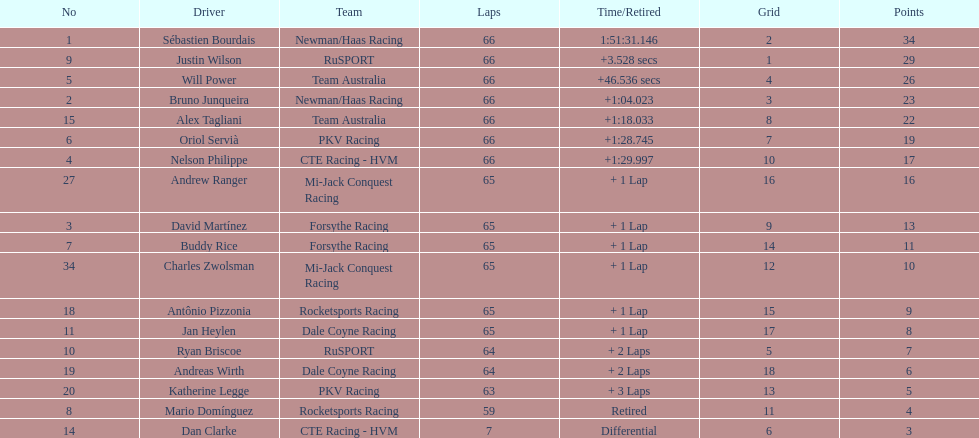How many drivers did not make more than 60 laps? 2. Write the full table. {'header': ['No', 'Driver', 'Team', 'Laps', 'Time/Retired', 'Grid', 'Points'], 'rows': [['1', 'Sébastien Bourdais', 'Newman/Haas Racing', '66', '1:51:31.146', '2', '34'], ['9', 'Justin Wilson', 'RuSPORT', '66', '+3.528 secs', '1', '29'], ['5', 'Will Power', 'Team Australia', '66', '+46.536 secs', '4', '26'], ['2', 'Bruno Junqueira', 'Newman/Haas Racing', '66', '+1:04.023', '3', '23'], ['15', 'Alex Tagliani', 'Team Australia', '66', '+1:18.033', '8', '22'], ['6', 'Oriol Servià', 'PKV Racing', '66', '+1:28.745', '7', '19'], ['4', 'Nelson Philippe', 'CTE Racing - HVM', '66', '+1:29.997', '10', '17'], ['27', 'Andrew Ranger', 'Mi-Jack Conquest Racing', '65', '+ 1 Lap', '16', '16'], ['3', 'David Martínez', 'Forsythe Racing', '65', '+ 1 Lap', '9', '13'], ['7', 'Buddy Rice', 'Forsythe Racing', '65', '+ 1 Lap', '14', '11'], ['34', 'Charles Zwolsman', 'Mi-Jack Conquest Racing', '65', '+ 1 Lap', '12', '10'], ['18', 'Antônio Pizzonia', 'Rocketsports Racing', '65', '+ 1 Lap', '15', '9'], ['11', 'Jan Heylen', 'Dale Coyne Racing', '65', '+ 1 Lap', '17', '8'], ['10', 'Ryan Briscoe', 'RuSPORT', '64', '+ 2 Laps', '5', '7'], ['19', 'Andreas Wirth', 'Dale Coyne Racing', '64', '+ 2 Laps', '18', '6'], ['20', 'Katherine Legge', 'PKV Racing', '63', '+ 3 Laps', '13', '5'], ['8', 'Mario Domínguez', 'Rocketsports Racing', '59', 'Retired', '11', '4'], ['14', 'Dan Clarke', 'CTE Racing - HVM', '7', 'Differential', '6', '3']]} 